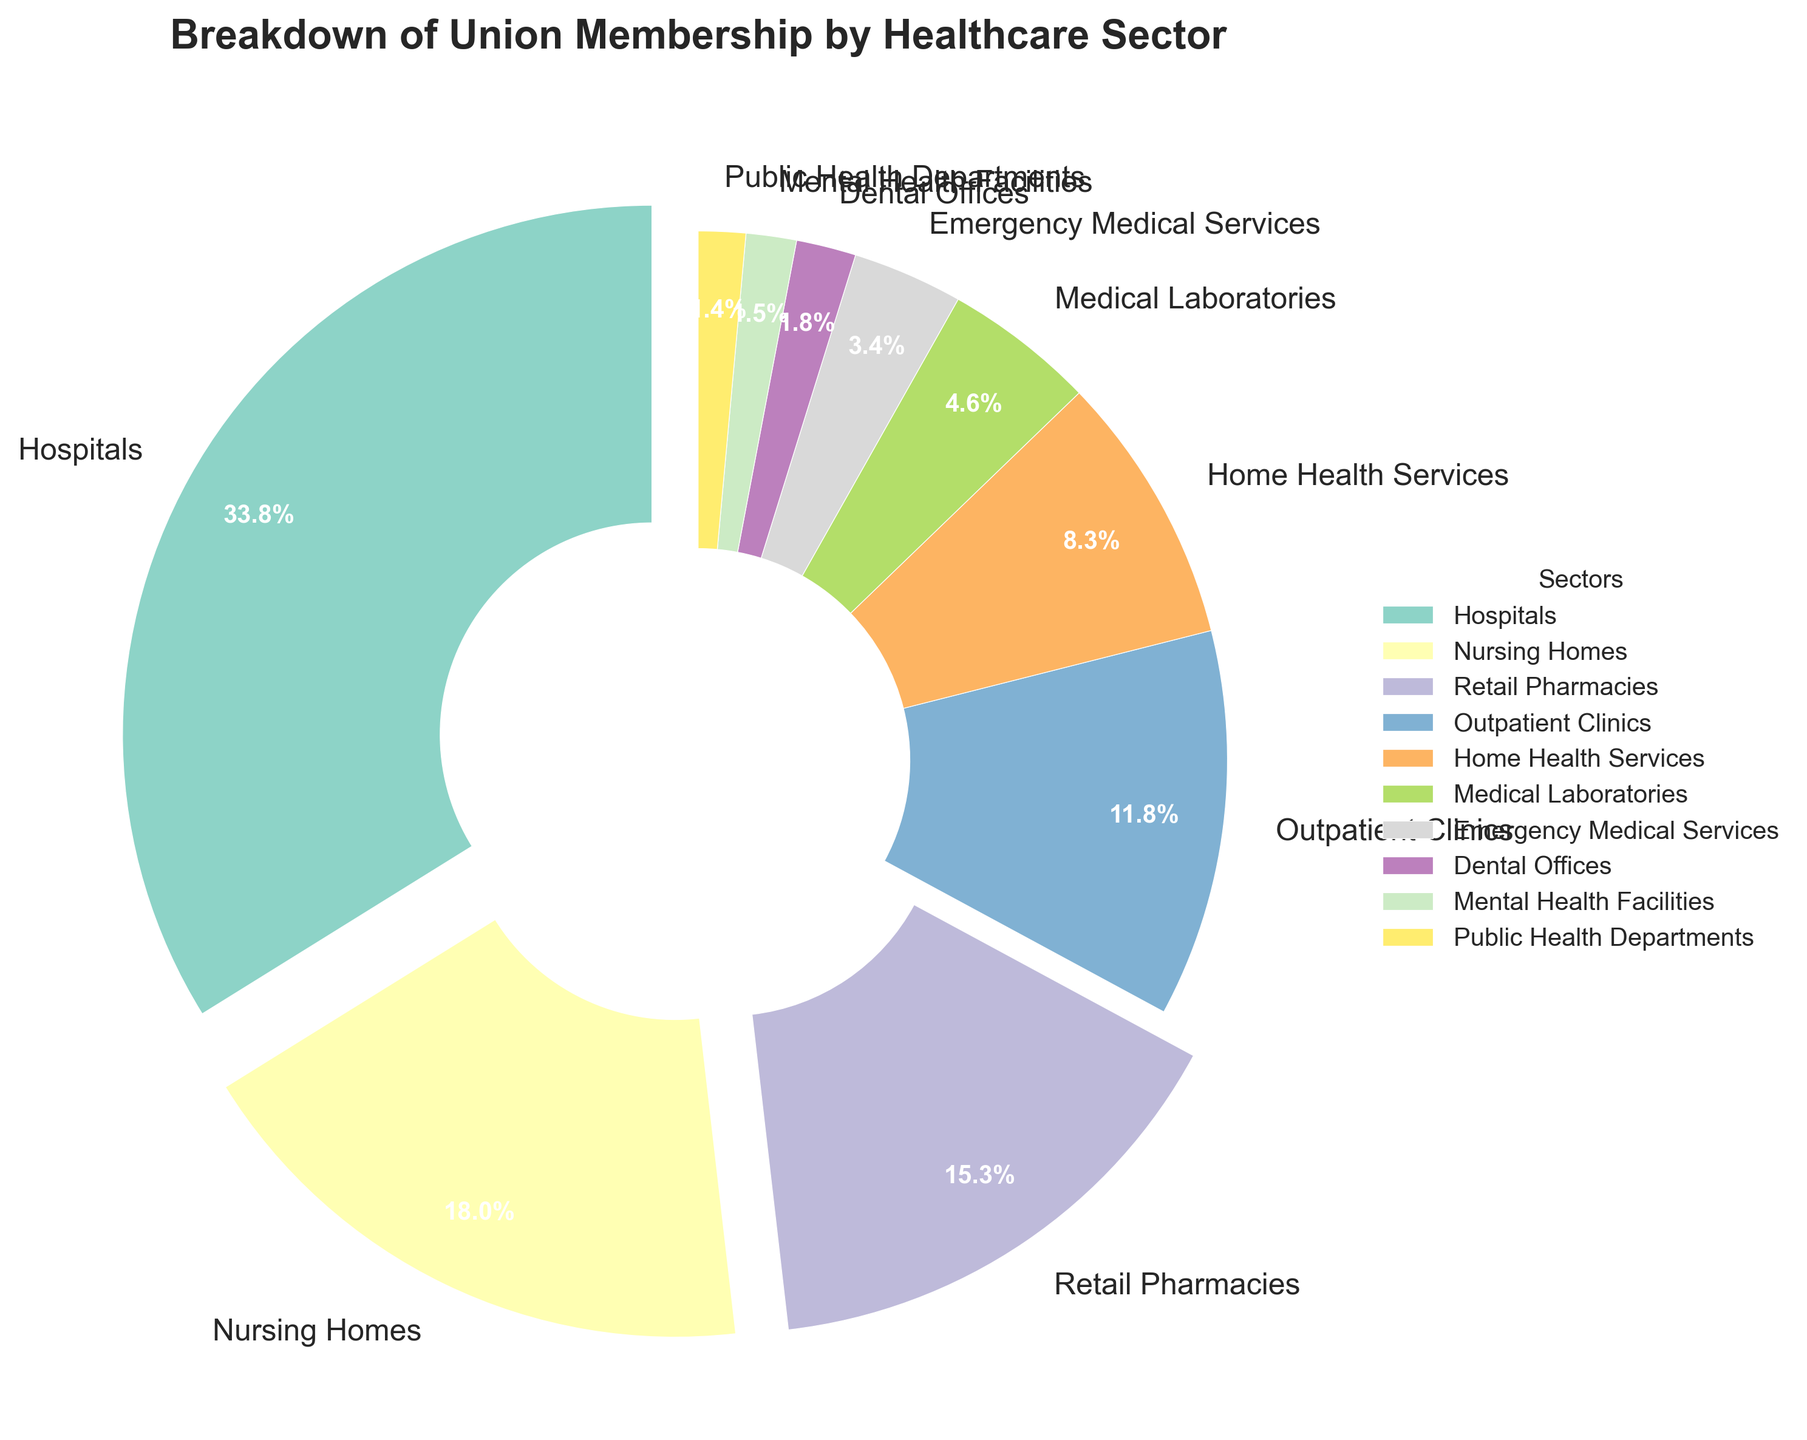Which healthcare sector has the highest union membership percentage? The sector with the highest percentage can be found by identifying the largest wedge in the pie chart. Hospitals have the largest wedge.
Answer: Hospitals Which healthcare sector has the smallest union membership percentage? The sector with the smallest percentage can be found by identifying the smallest wedge in the pie chart. Public Health Departments have the smallest wedge.
Answer: Public Health Departments What is the combined percentage of union membership in Retail Pharmacies and Outpatient Clinics? To get the combined percentage, sum the percentages for Retail Pharmacies and Outpatient Clinics. Retail Pharmacies is 15.9% and Outpatient Clinics is 12.3%. So, the combined percentage is 15.9% + 12.3%.
Answer: 28.2% How does the union membership percentage for Home Health Services compare to that for Medical Laboratories? Compare the percentages for both sectors. Home Health Services is 8.6% and Medical Laboratories is 4.8%. Home Health Services has a higher percentage.
Answer: Home Health Services is higher What percentage of union membership is in Dental Offices, Mental Health Facilities, and Public Health Departments combined? Sum the percentages for all three sectors: Dental Offices (1.9%), Mental Health Facilities (1.6%), and Public Health Departments (1.5%). The combined percentage is 1.9% + 1.6% + 1.5%.
Answer: 5.0% Which sectors have a union membership percentage higher than 20%? Identify sectors with percentages above 20%. Hospitals have 35.2%, which is the only sector above 20%.
Answer: Hospitals What are the sectors with more union membership than Retail Pharmacies? Identify sectors with a higher percentage than Retail Pharmacies (15.9%). Hospitals (35.2%) and Nursing Homes (18.7%) have higher percentages.
Answer: Hospitals, Nursing Homes What percentage is represented by sectors with less than 5% union membership? Sum the percentages for sectors with less than 5%. Medical Laboratories (4.8%), Emergency Medical Services (3.5%), Dental Offices (1.9%), Mental Health Facilities (1.6%), and Public Health Departments (1.5%). The combined percentage is 4.8% + 3.5% + 1.9% + 1.6% + 1.5%.
Answer: 13.3% Which sectors are represented by wedges with the same color scheme? Identify sectors with visually identical color schemes. In a pie chart, colors are evenly distributed and unique due to the use of distinct shades from the colormap, implying no two sectors share the same color.
Answer: No sectors 